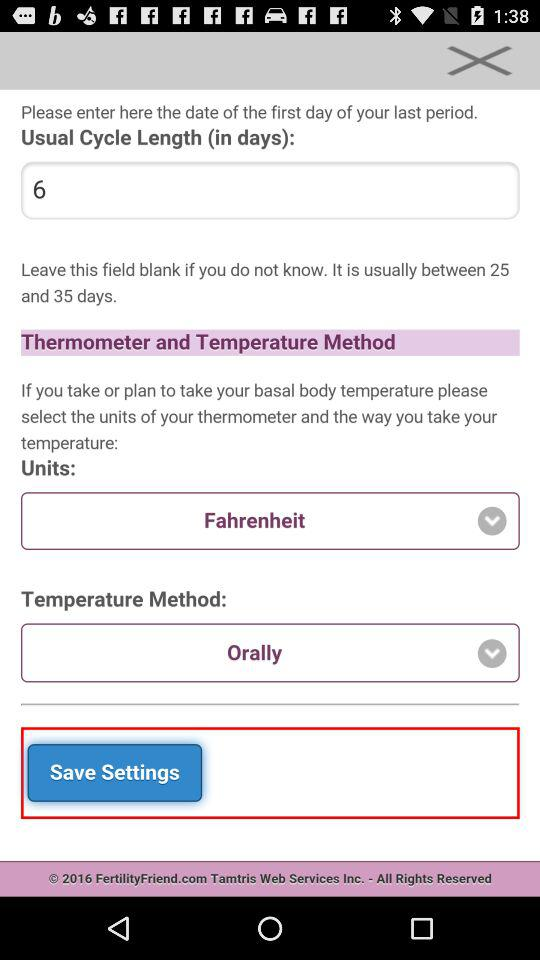What method is selected for temperature measurement? For temperature measurement, the oral method is selected. 